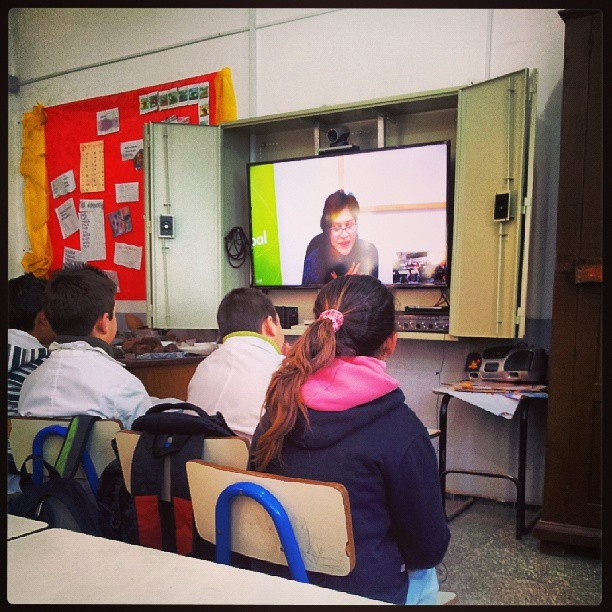Describe the objects in this image and their specific colors. I can see people in black, navy, maroon, and violet tones, tv in black, lavender, purple, and yellow tones, chair in black, tan, darkgray, and navy tones, people in black, lavender, darkgray, and lightgray tones, and backpack in black, maroon, and gray tones in this image. 